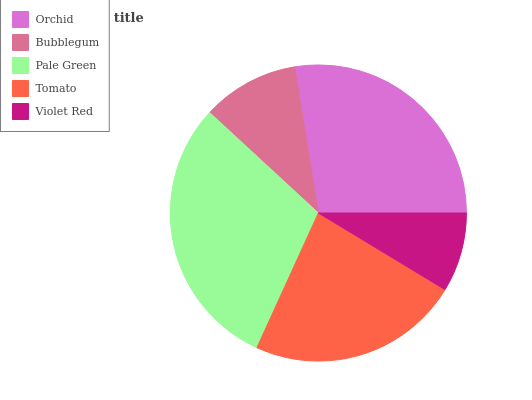Is Violet Red the minimum?
Answer yes or no. Yes. Is Pale Green the maximum?
Answer yes or no. Yes. Is Bubblegum the minimum?
Answer yes or no. No. Is Bubblegum the maximum?
Answer yes or no. No. Is Orchid greater than Bubblegum?
Answer yes or no. Yes. Is Bubblegum less than Orchid?
Answer yes or no. Yes. Is Bubblegum greater than Orchid?
Answer yes or no. No. Is Orchid less than Bubblegum?
Answer yes or no. No. Is Tomato the high median?
Answer yes or no. Yes. Is Tomato the low median?
Answer yes or no. Yes. Is Bubblegum the high median?
Answer yes or no. No. Is Violet Red the low median?
Answer yes or no. No. 